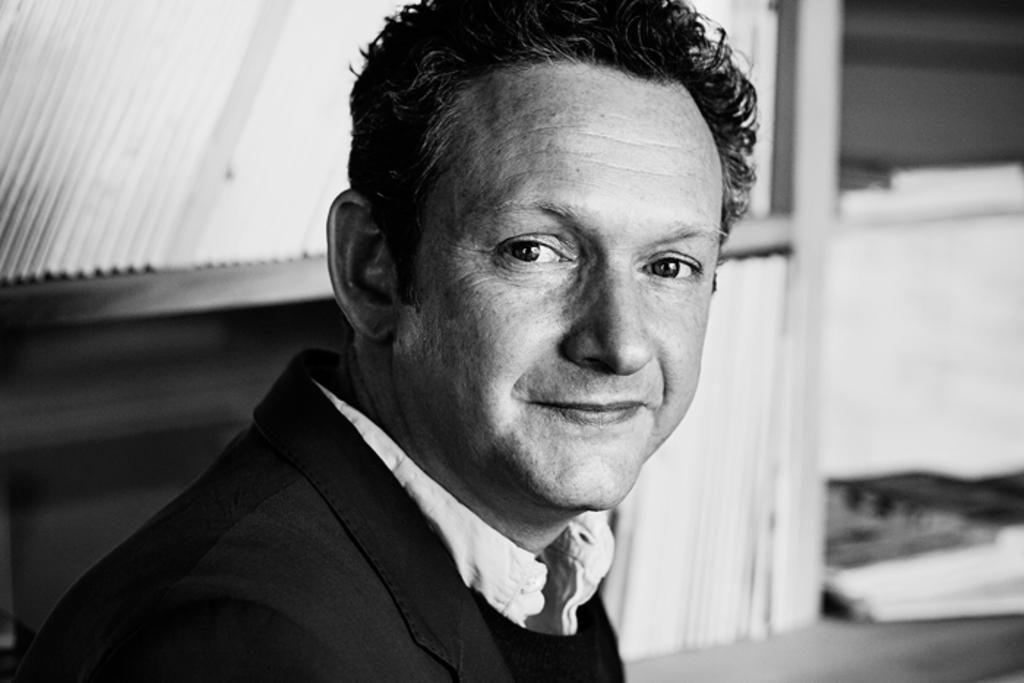What type of picture is in the image? The image contains a black and white picture. Can you describe the person in the picture? The person is wearing a white shirt and a black blazer. What is the person doing in the picture? The person is smiling. How is the background of the picture depicted? The background of the picture is blurry. What type of card is the person holding in the image? There is no card present in the image; the person is not holding anything. Can you describe the fish swimming in the background of the image? There are no fish present in the image; the background is blurry but does not contain any fish. 